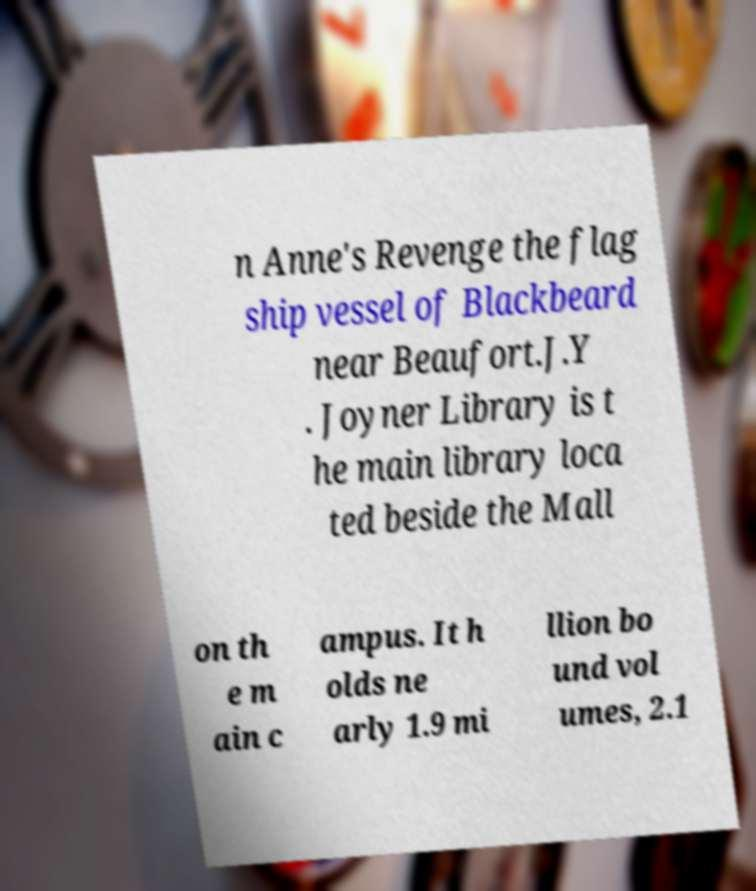What messages or text are displayed in this image? I need them in a readable, typed format. n Anne's Revenge the flag ship vessel of Blackbeard near Beaufort.J.Y . Joyner Library is t he main library loca ted beside the Mall on th e m ain c ampus. It h olds ne arly 1.9 mi llion bo und vol umes, 2.1 